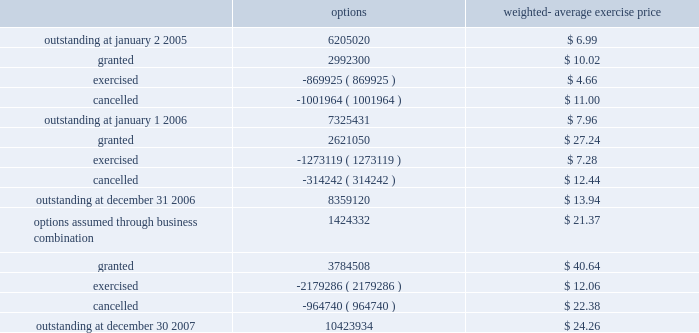Stock options 2005 stock and incentive plan in june 2005 , the stockholders of the company approved the 2005 stock and incentive plan ( the 2005 stock plan ) .
Upon adoption of the 2005 stock plan , issuance of options under the company 2019s existing 2000 stock plan ceased .
Additionally , in connection with the acquisition of solexa , the company assumed stock options granted under the 2005 solexa equity incentive plan ( the 2005 solexa equity plan ) .
As of december 30 , 2007 , an aggregate of up to 13485619 shares of the company 2019s common stock were reserved for issuance under the 2005 stock plan and the 2005 solexa equity plan .
The 2005 stock plan provides for an automatic annual increase in the shares reserved for issuance by the lesser of 5% ( 5 % ) of outstanding shares of the company 2019s common stock on the last day of the immediately preceding fiscal year , 1200000 shares or such lesser amount as determined by the company 2019s board of directors .
As of december 30 , 2007 , options to purchase 1834384 shares remained available for future grant under the 2005 stock plan and 2005 solexa equity plan .
The company 2019s stock option activity under all stock option plans from january 2 , 2005 through december 30 , 2007 is as follows : options weighted- average exercise price .
Illumina , inc .
Notes to consolidated financial statements 2014 ( continued ) .
What is the total value of granted options in 2007 , in millions? 
Computations: ((3784508 * 40.64) / 1000000)
Answer: 153.80241. 